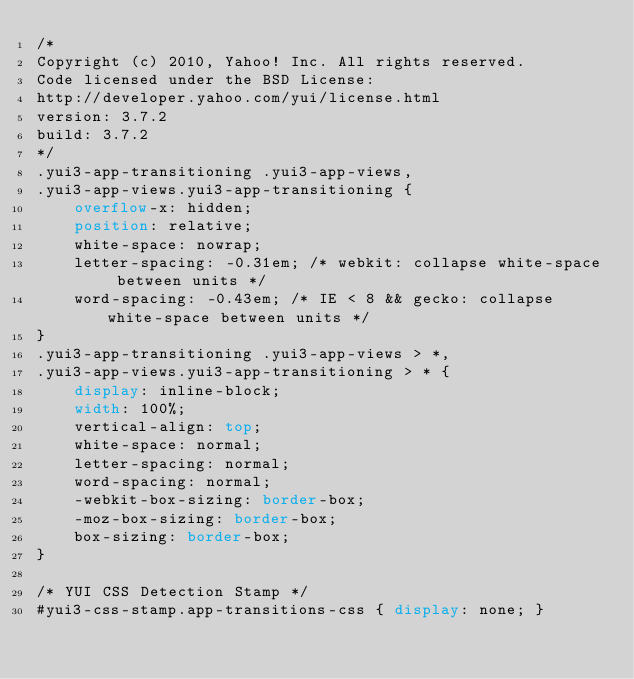Convert code to text. <code><loc_0><loc_0><loc_500><loc_500><_CSS_>/*
Copyright (c) 2010, Yahoo! Inc. All rights reserved.
Code licensed under the BSD License:
http://developer.yahoo.com/yui/license.html
version: 3.7.2
build: 3.7.2
*/
.yui3-app-transitioning .yui3-app-views,
.yui3-app-views.yui3-app-transitioning {
    overflow-x: hidden;
    position: relative;
    white-space: nowrap;
    letter-spacing: -0.31em; /* webkit: collapse white-space between units */
    word-spacing: -0.43em; /* IE < 8 && gecko: collapse white-space between units */
}
.yui3-app-transitioning .yui3-app-views > *,
.yui3-app-views.yui3-app-transitioning > * {
    display: inline-block;
    width: 100%;
    vertical-align: top;
    white-space: normal;
    letter-spacing: normal;
    word-spacing: normal;
    -webkit-box-sizing: border-box;
    -moz-box-sizing: border-box;
    box-sizing: border-box;
}

/* YUI CSS Detection Stamp */
#yui3-css-stamp.app-transitions-css { display: none; }
</code> 